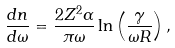Convert formula to latex. <formula><loc_0><loc_0><loc_500><loc_500>\frac { d n } { d \omega } = \frac { 2 Z ^ { 2 } \alpha } { \pi \omega } \ln \left ( \frac { \gamma } { \omega R } \right ) ,</formula> 